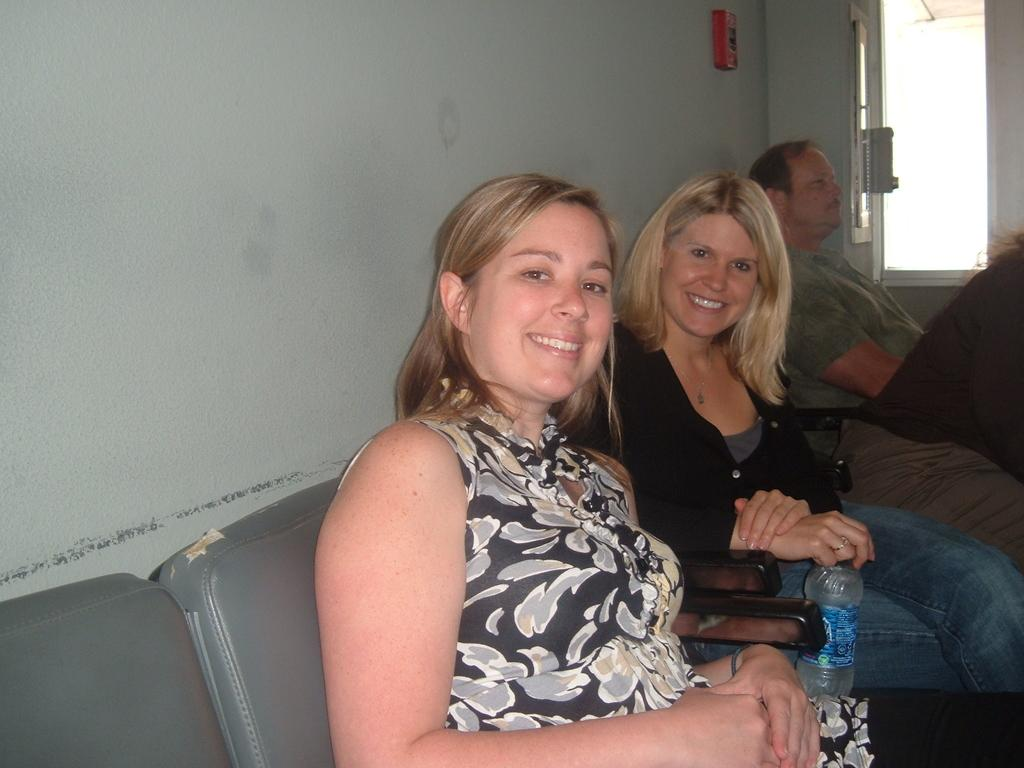How many people are in the image? There are 4 people in the image. Can you describe the gender of the people in the image? Two of the people are women. What expression do the women have in the image? The women are smiling. What are the people doing in the image? The people are sitting on chairs. What type of stitch is being used to sew the blood-stained sheets in the bedroom? There is no mention of stitching, blood, or a bedroom in the image, so it is not possible to answer that question. 